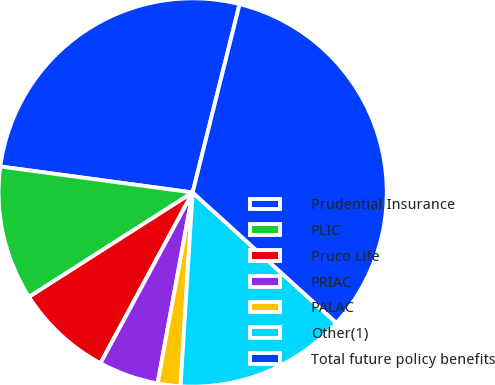<chart> <loc_0><loc_0><loc_500><loc_500><pie_chart><fcel>Prudential Insurance<fcel>PLIC<fcel>Pruco Life<fcel>PRIAC<fcel>PALAC<fcel>Other(1)<fcel>Total future policy benefits<nl><fcel>26.75%<fcel>11.18%<fcel>8.08%<fcel>4.99%<fcel>1.89%<fcel>14.27%<fcel>32.84%<nl></chart> 